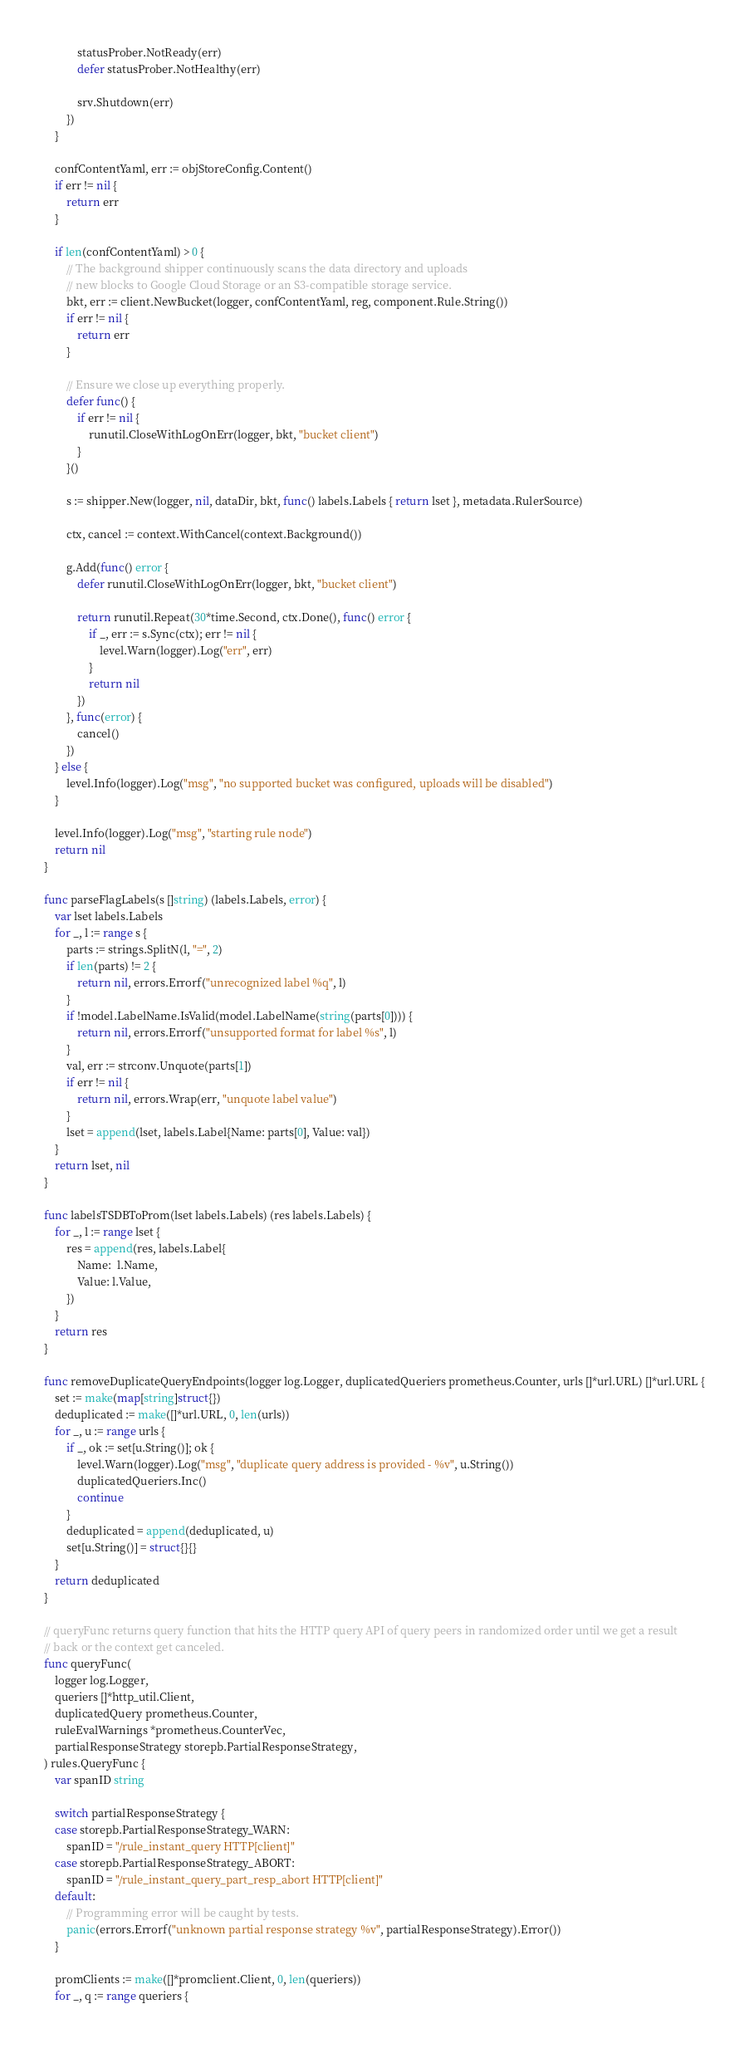Convert code to text. <code><loc_0><loc_0><loc_500><loc_500><_Go_>			statusProber.NotReady(err)
			defer statusProber.NotHealthy(err)

			srv.Shutdown(err)
		})
	}

	confContentYaml, err := objStoreConfig.Content()
	if err != nil {
		return err
	}

	if len(confContentYaml) > 0 {
		// The background shipper continuously scans the data directory and uploads
		// new blocks to Google Cloud Storage or an S3-compatible storage service.
		bkt, err := client.NewBucket(logger, confContentYaml, reg, component.Rule.String())
		if err != nil {
			return err
		}

		// Ensure we close up everything properly.
		defer func() {
			if err != nil {
				runutil.CloseWithLogOnErr(logger, bkt, "bucket client")
			}
		}()

		s := shipper.New(logger, nil, dataDir, bkt, func() labels.Labels { return lset }, metadata.RulerSource)

		ctx, cancel := context.WithCancel(context.Background())

		g.Add(func() error {
			defer runutil.CloseWithLogOnErr(logger, bkt, "bucket client")

			return runutil.Repeat(30*time.Second, ctx.Done(), func() error {
				if _, err := s.Sync(ctx); err != nil {
					level.Warn(logger).Log("err", err)
				}
				return nil
			})
		}, func(error) {
			cancel()
		})
	} else {
		level.Info(logger).Log("msg", "no supported bucket was configured, uploads will be disabled")
	}

	level.Info(logger).Log("msg", "starting rule node")
	return nil
}

func parseFlagLabels(s []string) (labels.Labels, error) {
	var lset labels.Labels
	for _, l := range s {
		parts := strings.SplitN(l, "=", 2)
		if len(parts) != 2 {
			return nil, errors.Errorf("unrecognized label %q", l)
		}
		if !model.LabelName.IsValid(model.LabelName(string(parts[0]))) {
			return nil, errors.Errorf("unsupported format for label %s", l)
		}
		val, err := strconv.Unquote(parts[1])
		if err != nil {
			return nil, errors.Wrap(err, "unquote label value")
		}
		lset = append(lset, labels.Label{Name: parts[0], Value: val})
	}
	return lset, nil
}

func labelsTSDBToProm(lset labels.Labels) (res labels.Labels) {
	for _, l := range lset {
		res = append(res, labels.Label{
			Name:  l.Name,
			Value: l.Value,
		})
	}
	return res
}

func removeDuplicateQueryEndpoints(logger log.Logger, duplicatedQueriers prometheus.Counter, urls []*url.URL) []*url.URL {
	set := make(map[string]struct{})
	deduplicated := make([]*url.URL, 0, len(urls))
	for _, u := range urls {
		if _, ok := set[u.String()]; ok {
			level.Warn(logger).Log("msg", "duplicate query address is provided - %v", u.String())
			duplicatedQueriers.Inc()
			continue
		}
		deduplicated = append(deduplicated, u)
		set[u.String()] = struct{}{}
	}
	return deduplicated
}

// queryFunc returns query function that hits the HTTP query API of query peers in randomized order until we get a result
// back or the context get canceled.
func queryFunc(
	logger log.Logger,
	queriers []*http_util.Client,
	duplicatedQuery prometheus.Counter,
	ruleEvalWarnings *prometheus.CounterVec,
	partialResponseStrategy storepb.PartialResponseStrategy,
) rules.QueryFunc {
	var spanID string

	switch partialResponseStrategy {
	case storepb.PartialResponseStrategy_WARN:
		spanID = "/rule_instant_query HTTP[client]"
	case storepb.PartialResponseStrategy_ABORT:
		spanID = "/rule_instant_query_part_resp_abort HTTP[client]"
	default:
		// Programming error will be caught by tests.
		panic(errors.Errorf("unknown partial response strategy %v", partialResponseStrategy).Error())
	}

	promClients := make([]*promclient.Client, 0, len(queriers))
	for _, q := range queriers {</code> 